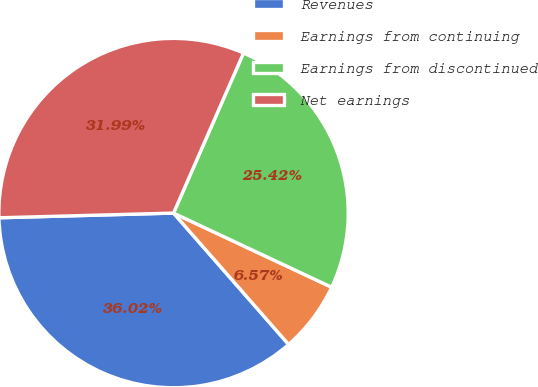<chart> <loc_0><loc_0><loc_500><loc_500><pie_chart><fcel>Revenues<fcel>Earnings from continuing<fcel>Earnings from discontinued<fcel>Net earnings<nl><fcel>36.02%<fcel>6.57%<fcel>25.42%<fcel>31.99%<nl></chart> 